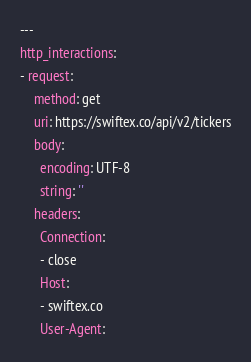<code> <loc_0><loc_0><loc_500><loc_500><_YAML_>---
http_interactions:
- request:
    method: get
    uri: https://swiftex.co/api/v2/tickers
    body:
      encoding: UTF-8
      string: ''
    headers:
      Connection:
      - close
      Host:
      - swiftex.co
      User-Agent:</code> 